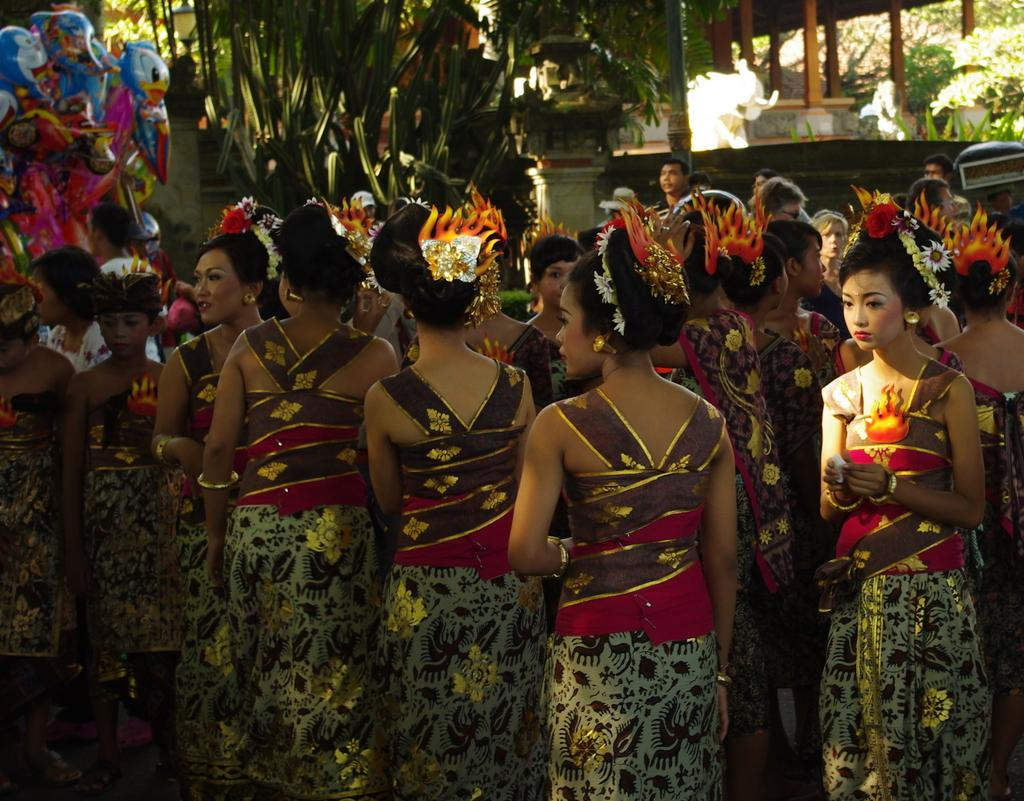How many people are in the image? There is a group of people standing in the image. What can be seen in the background of the image? There are trees and wooden pillars in the background of the image. What type of wood can be seen burning in the image? There is no wood or flame present in the image; it only features a group of people and trees in the background. 